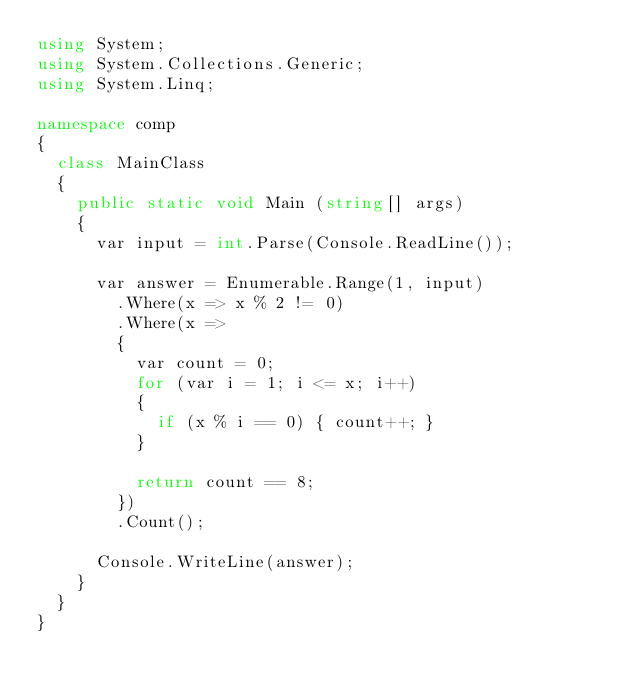Convert code to text. <code><loc_0><loc_0><loc_500><loc_500><_C#_>using System;
using System.Collections.Generic;
using System.Linq;

namespace comp
{
	class MainClass
	{
		public static void Main (string[] args)
		{
			var input = int.Parse(Console.ReadLine());

			var answer = Enumerable.Range(1, input)
				.Where(x => x % 2 != 0)
				.Where(x =>
				{
					var count = 0;
					for (var i = 1; i <= x; i++)
					{
						if (x % i == 0) { count++; }
					}

					return count == 8;
				})
				.Count();

			Console.WriteLine(answer);
		}
	}
}
</code> 